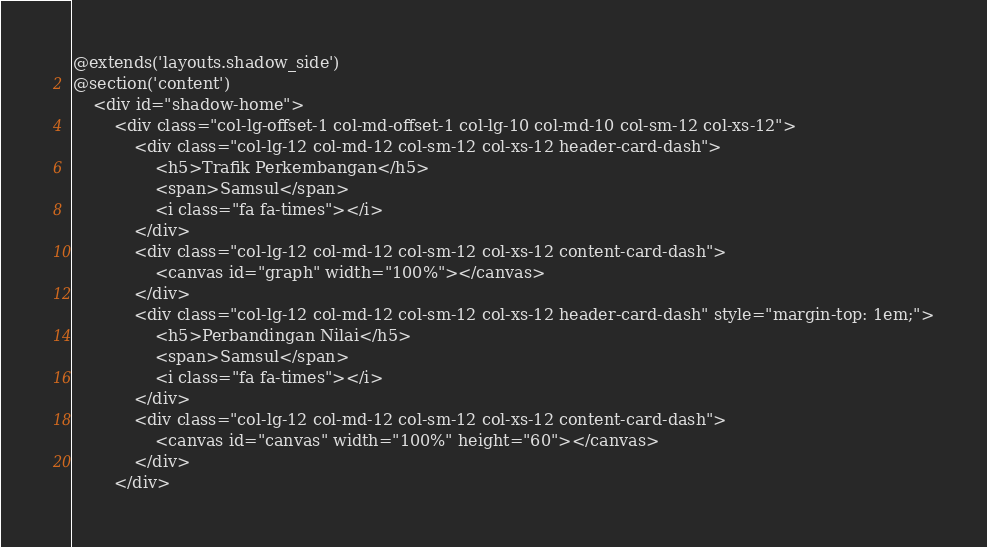<code> <loc_0><loc_0><loc_500><loc_500><_PHP_>@extends('layouts.shadow_side')
@section('content')
    <div id="shadow-home">
        <div class="col-lg-offset-1 col-md-offset-1 col-lg-10 col-md-10 col-sm-12 col-xs-12">
            <div class="col-lg-12 col-md-12 col-sm-12 col-xs-12 header-card-dash">
                <h5>Trafik Perkembangan</h5>
                <span>Samsul</span>
                <i class="fa fa-times"></i>
            </div>
            <div class="col-lg-12 col-md-12 col-sm-12 col-xs-12 content-card-dash">
                <canvas id="graph" width="100%"></canvas>
            </div>
            <div class="col-lg-12 col-md-12 col-sm-12 col-xs-12 header-card-dash" style="margin-top: 1em;">
                <h5>Perbandingan Nilai</h5>
                <span>Samsul</span>
                <i class="fa fa-times"></i>
            </div>
            <div class="col-lg-12 col-md-12 col-sm-12 col-xs-12 content-card-dash">
                <canvas id="canvas" width="100%" height="60"></canvas>
            </div>
        </div></code> 